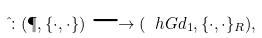<formula> <loc_0><loc_0><loc_500><loc_500>\hat { \L } \colon ( \P , \{ \cdot , \cdot \} ) \longrightarrow ( \ h G d _ { 1 } , \{ \cdot , \cdot \} _ { R } ) ,</formula> 